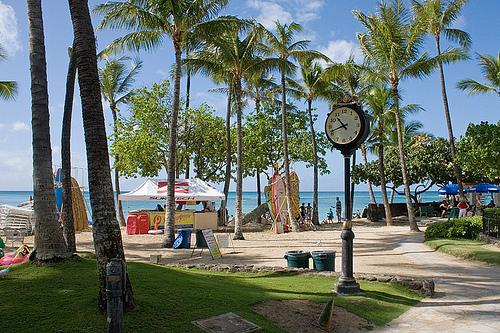These people are most likely on what type of event? Please explain your reasoning. vacation. Many people travel to the beach for relaxation. 